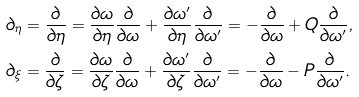<formula> <loc_0><loc_0><loc_500><loc_500>& \partial _ { \eta } = \frac { \partial } { \partial \eta } = \frac { \partial \omega } { \partial \eta } \frac { \partial } { \partial \omega } + \frac { \partial \omega ^ { \prime } } { \partial \eta } \frac { \partial } { \partial \omega ^ { \prime } } = - \frac { \partial } { \partial \omega } + Q \frac { \partial } { \partial \omega ^ { \prime } } , \\ & \partial _ { \xi } = \frac { \partial } { \partial \zeta } = \frac { \partial \omega } { \partial \zeta } \frac { \partial } { \partial \omega } + \frac { \partial \omega ^ { \prime } } { \partial \zeta } \frac { \partial } { \partial \omega ^ { \prime } } = - \frac { \partial } { \partial \omega } - P \frac { \partial } { \partial \omega ^ { \prime } } .</formula> 